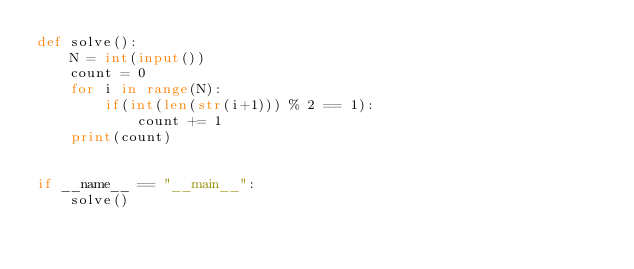Convert code to text. <code><loc_0><loc_0><loc_500><loc_500><_Python_>def solve():
    N = int(input())
    count = 0
    for i in range(N):
        if(int(len(str(i+1))) % 2 == 1):
            count += 1
    print(count)


if __name__ == "__main__":
    solve()</code> 